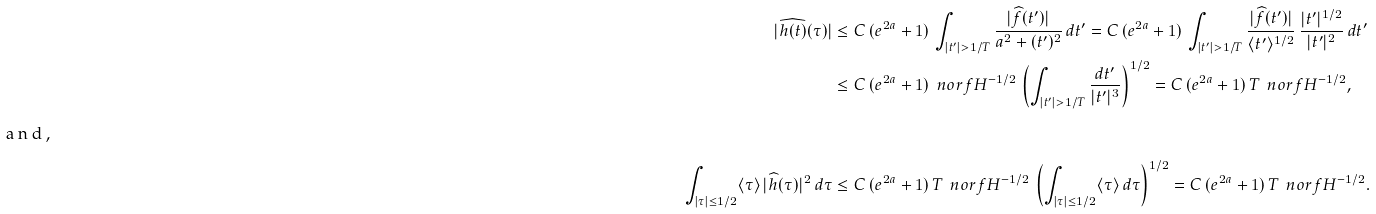Convert formula to latex. <formula><loc_0><loc_0><loc_500><loc_500>| \widehat { h ( t ) } ( \tau ) | & \leq C \, ( e ^ { 2 a } + 1 ) \, \int _ { | t ^ { \prime } | > 1 / T } \frac { | \widehat { f } ( t ^ { \prime } ) | } { a ^ { 2 } + ( t ^ { \prime } ) ^ { 2 } } \, d t ^ { \prime } = C \, ( e ^ { 2 a } + 1 ) \, \int _ { | t ^ { \prime } | > 1 / T } \frac { | \widehat { f } ( t ^ { \prime } ) | } { \langle t ^ { \prime } \rangle ^ { 1 / 2 } } \, \frac { | t ^ { \prime } | ^ { 1 / 2 } } { | t ^ { \prime } | ^ { 2 } } \, d t ^ { \prime } \\ & \leq C \, ( e ^ { 2 a } + 1 ) \, \ n o r { f } { H ^ { - 1 / 2 } } \, \left ( \int _ { | t ^ { \prime } | > 1 / T } \frac { d t ^ { \prime } } { | t ^ { \prime } | ^ { 3 } } \right ) ^ { 1 / 2 } = C \, ( e ^ { 2 a } + 1 ) \, T \, \ n o r { f } { H ^ { - 1 / 2 } } , \\ \intertext { a n d , } \int _ { | \tau | \leq 1 / 2 } \langle \tau \rangle \, | \widehat { h } ( \tau ) | ^ { 2 } \, d \tau & \leq C \, ( e ^ { 2 a } + 1 ) \, T \, \ n o r { f } { H ^ { - 1 / 2 } } \, \left ( \int _ { | \tau | \leq 1 / 2 } \langle \tau \rangle \, d \tau \right ) ^ { 1 / 2 } = C \, ( e ^ { 2 a } + 1 ) \, T \, \ n o r { f } { H ^ { - 1 / 2 } } .</formula> 